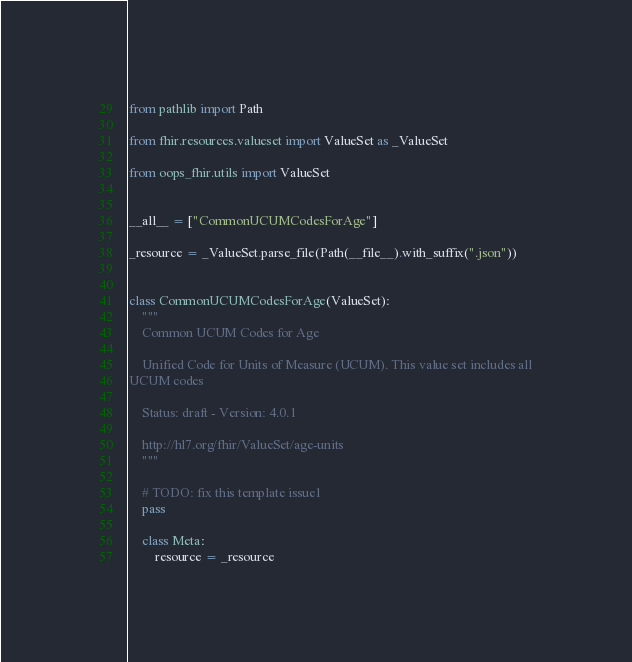Convert code to text. <code><loc_0><loc_0><loc_500><loc_500><_Python_>from pathlib import Path

from fhir.resources.valueset import ValueSet as _ValueSet

from oops_fhir.utils import ValueSet


__all__ = ["CommonUCUMCodesForAge"]

_resource = _ValueSet.parse_file(Path(__file__).with_suffix(".json"))


class CommonUCUMCodesForAge(ValueSet):
    """
    Common UCUM Codes for Age

    Unified Code for Units of Measure (UCUM). This value set includes all
UCUM codes

    Status: draft - Version: 4.0.1

    http://hl7.org/fhir/ValueSet/age-units
    """

    # TODO: fix this template issue1
    pass

    class Meta:
        resource = _resource
</code> 